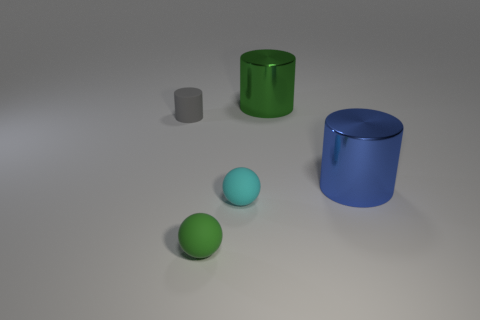Add 5 tiny brown balls. How many objects exist? 10 Subtract all spheres. How many objects are left? 3 Add 4 tiny cyan spheres. How many tiny cyan spheres exist? 5 Subtract 1 gray cylinders. How many objects are left? 4 Subtract all large cylinders. Subtract all cyan objects. How many objects are left? 2 Add 4 gray rubber objects. How many gray rubber objects are left? 5 